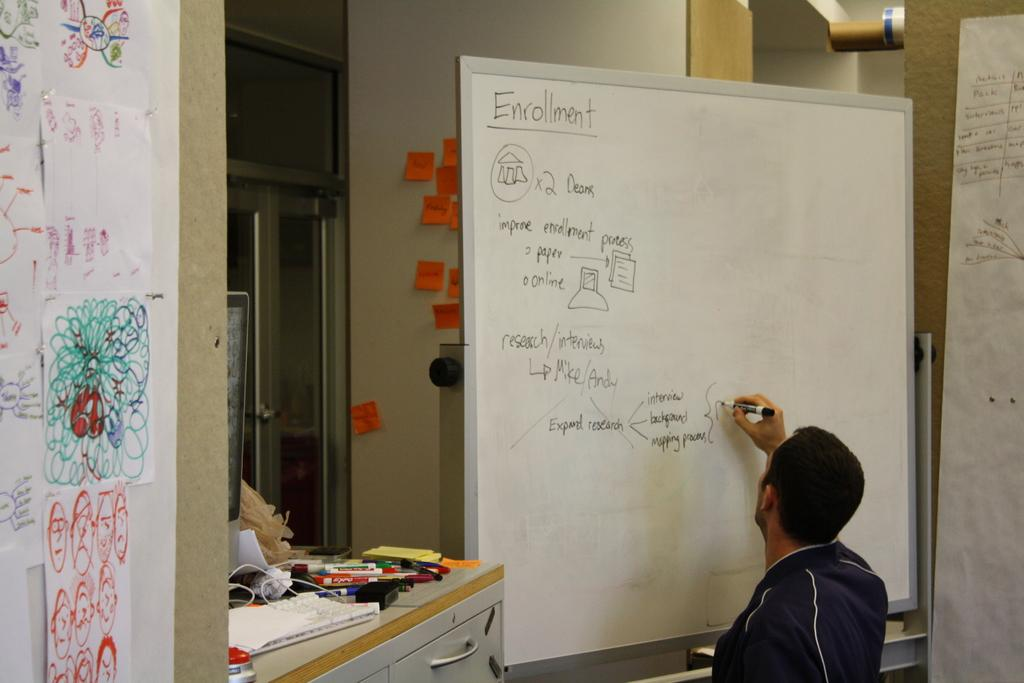<image>
Render a clear and concise summary of the photo. A man is making notes about enrollment on the board. 